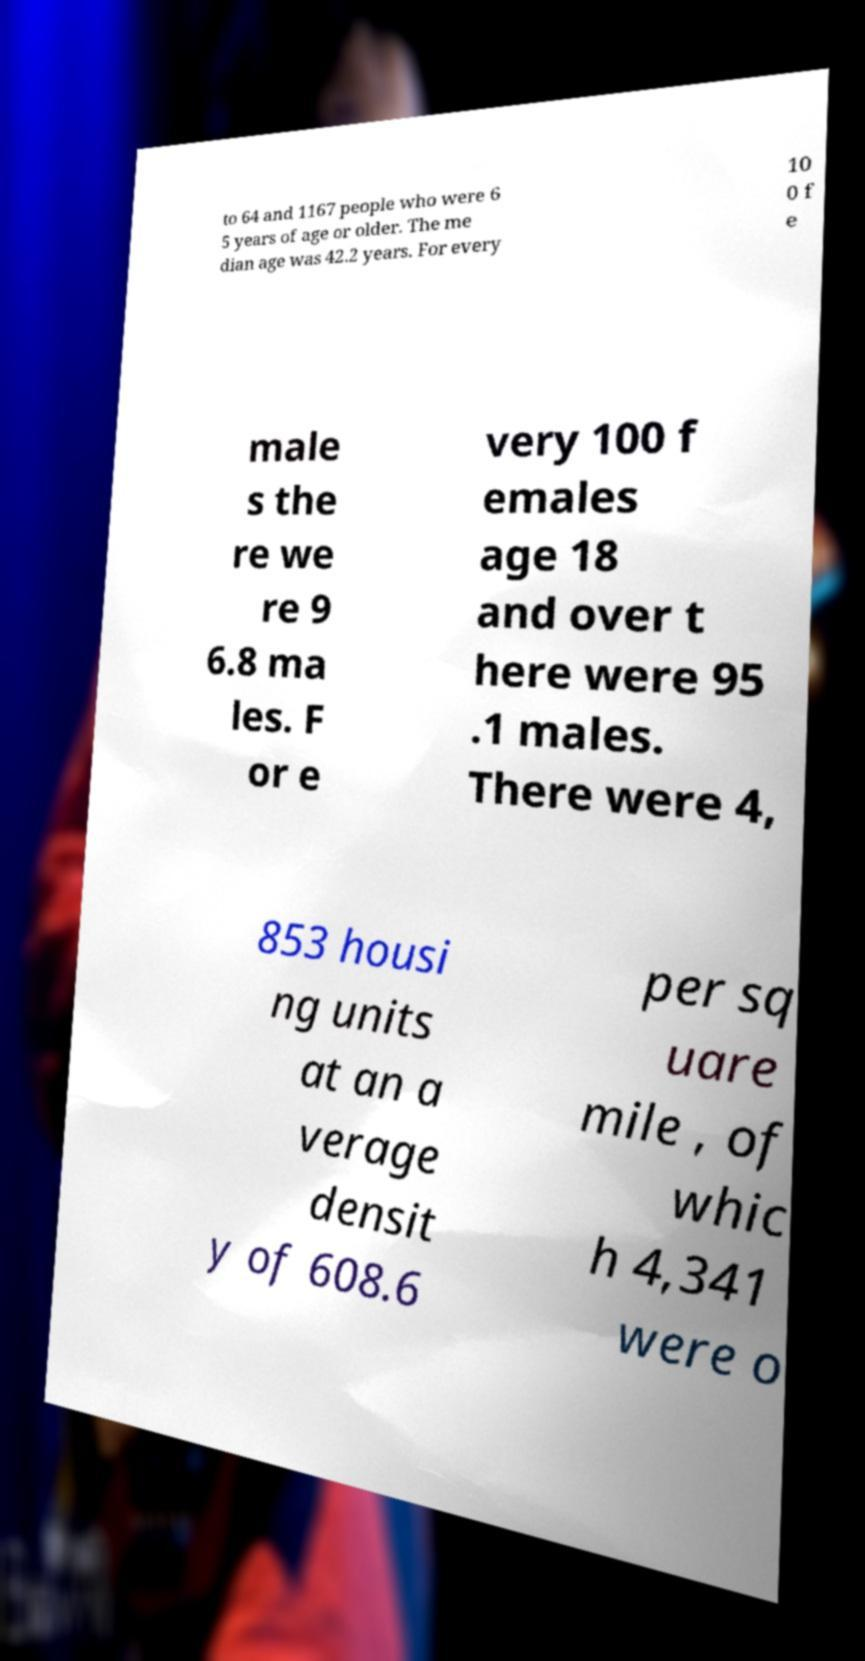Can you read and provide the text displayed in the image?This photo seems to have some interesting text. Can you extract and type it out for me? to 64 and 1167 people who were 6 5 years of age or older. The me dian age was 42.2 years. For every 10 0 f e male s the re we re 9 6.8 ma les. F or e very 100 f emales age 18 and over t here were 95 .1 males. There were 4, 853 housi ng units at an a verage densit y of 608.6 per sq uare mile , of whic h 4,341 were o 